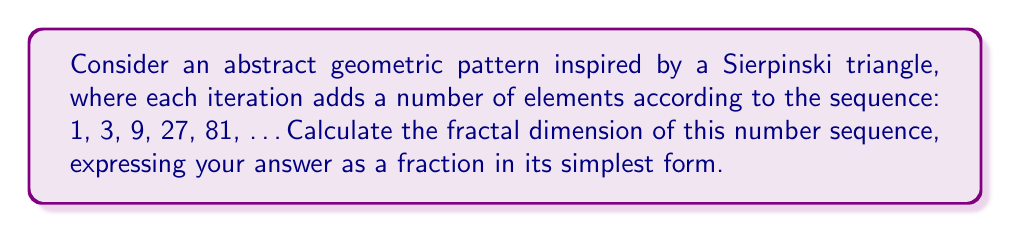Help me with this question. To calculate the fractal dimension of this sequence, we'll follow these steps:

1. Identify the scaling factor:
   Each iteration scales the number of elements by a factor of 3.

2. Identify the number of self-similar parts:
   Each iteration produces 3 times as many elements as the previous one.

3. Use the fractal dimension formula:
   $$D = \frac{\log(N)}{\log(1/r)}$$
   Where:
   $D$ is the fractal dimension
   $N$ is the number of self-similar parts
   $r$ is the scaling factor

4. Plug in the values:
   $$D = \frac{\log(3)}{\log(3)} = 1$$

5. Simplify:
   The result is already in its simplest form as a fraction: 1/1.

This fractal dimension of 1 indicates that the sequence grows in a way that fills a one-dimensional space, which aligns with the linear nature of a number sequence. This result creates an interesting parallel between the abstract geometric pattern and the numerical representation, much like how abstract art can represent mathematical concepts visually.
Answer: $1$ 